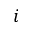<formula> <loc_0><loc_0><loc_500><loc_500>i</formula> 